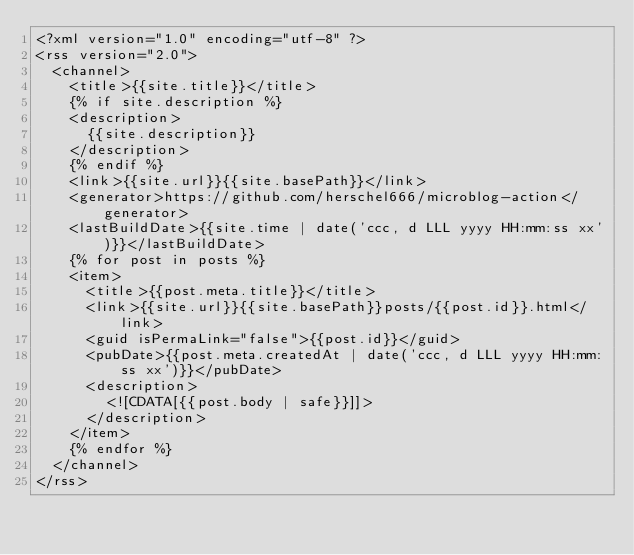Convert code to text. <code><loc_0><loc_0><loc_500><loc_500><_XML_><?xml version="1.0" encoding="utf-8" ?>
<rss version="2.0">
  <channel>
    <title>{{site.title}}</title>
    {% if site.description %}
    <description>
      {{site.description}}
    </description>
    {% endif %}
    <link>{{site.url}}{{site.basePath}}</link>
    <generator>https://github.com/herschel666/microblog-action</generator>
    <lastBuildDate>{{site.time | date('ccc, d LLL yyyy HH:mm:ss xx')}}</lastBuildDate>
    {% for post in posts %}
    <item>
      <title>{{post.meta.title}}</title>
      <link>{{site.url}}{{site.basePath}}posts/{{post.id}}.html</link>
      <guid isPermaLink="false">{{post.id}}</guid>
      <pubDate>{{post.meta.createdAt | date('ccc, d LLL yyyy HH:mm:ss xx')}}</pubDate>
      <description>
        <![CDATA[{{post.body | safe}}]]>
      </description>
    </item>
    {% endfor %}
  </channel>
</rss>
</code> 